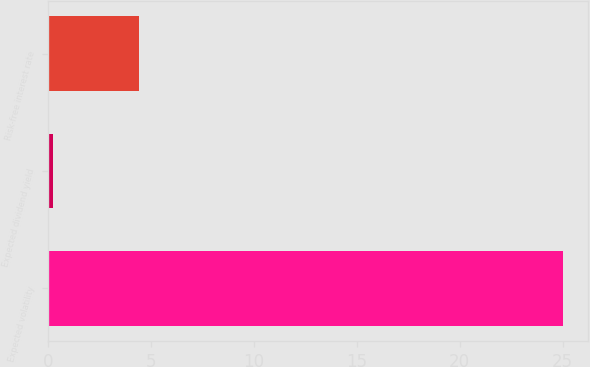<chart> <loc_0><loc_0><loc_500><loc_500><bar_chart><fcel>Expected volatility<fcel>Expected dividend yield<fcel>Risk-free interest rate<nl><fcel>25<fcel>0.25<fcel>4.4<nl></chart> 